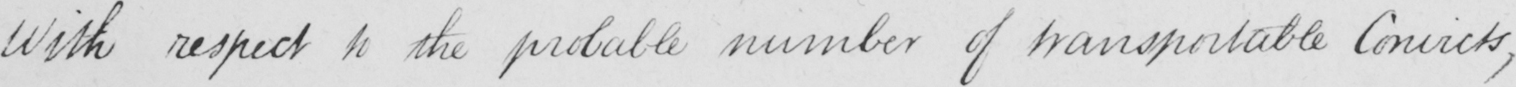Transcribe the text shown in this historical manuscript line. With respect to the probably number of transportable Convicts , 